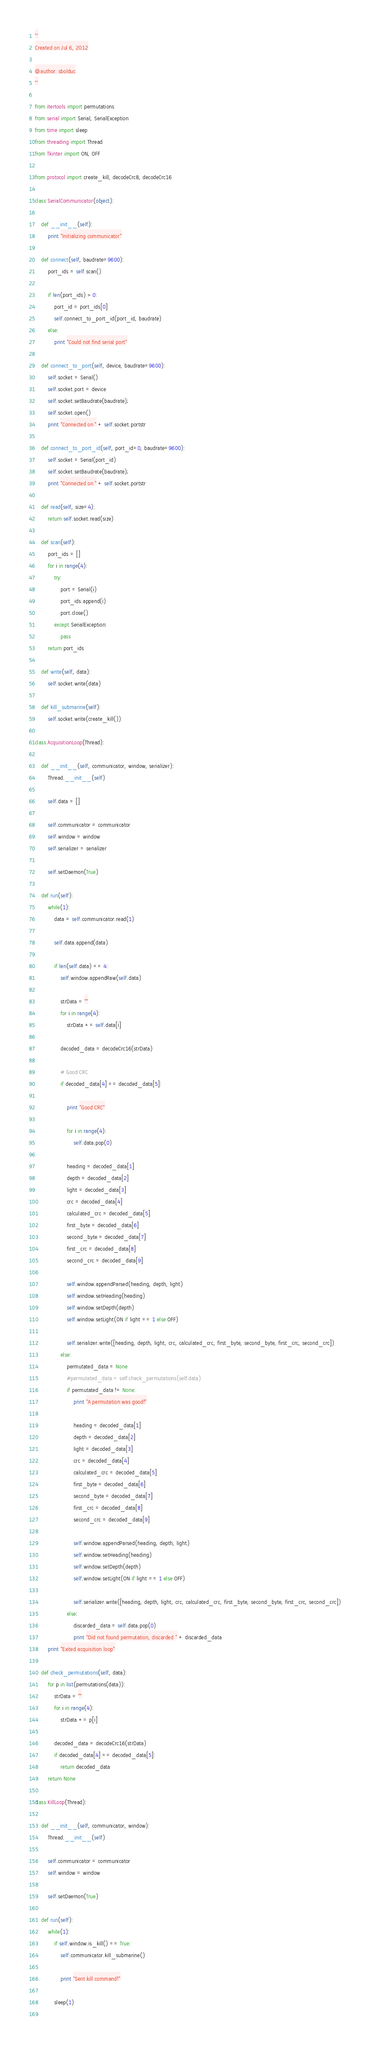<code> <loc_0><loc_0><loc_500><loc_500><_Python_>'''
Created on Jul 6, 2012

@author: sbolduc
'''

from itertools import permutations
from serial import Serial, SerialException
from time import sleep
from threading import Thread
from Tkinter import ON, OFF

from protocol import create_kill, decodeCrc8, decodeCrc16

class SerialCommunicator(object):

    def __init__(self):
        print "Initializing communicator"
            
    def connect(self, baudrate=9600):
        port_ids = self.scan()
        
        if len(port_ids) > 0:
            port_id = port_ids[0]
            self.connect_to_port_id(port_id, baudrate)
        else:
            print "Could not find serial port"
            
    def connect_to_port(self, device, baudrate=9600):
        self.socket = Serial()
        self.socket.port = device
        self.socket.setBaudrate(baudrate);
        self.socket.open()
        print "Connected on " + self.socket.portstr
        
    def connect_to_port_id(self, port_id=0, baudrate=9600):
        self.socket = Serial(port_id)
        self.socket.setBaudrate(baudrate);
        print "Connected on " + self.socket.portstr
        
    def read(self, size=4):
        return self.socket.read(size)
    
    def scan(self):
        port_ids = []
        for i in range(4):
            try:
                port = Serial(i)
                port_ids.append(i)
                port.close()
            except SerialException:
                pass
        return port_ids
    
    def write(self, data):
        self.socket.write(data)
    
    def kill_submarine(self):
        self.socket.write(create_kill())

class AcquisitionLoop(Thread):

    def __init__(self, communicator, window, serializer):
        Thread.__init__(self) 
        
        self.data = []
        
        self.communicator = communicator
        self.window = window
        self.serializer = serializer
        
        self.setDaemon(True)

    def run(self):
        while(1):
            data = self.communicator.read(1)
            
            self.data.append(data)
            
            if len(self.data) == 4:
                self.window.appendRaw(self.data)
                
                strData = ""
                for i in range(4):
                    strData += self.data[i]
                    
                decoded_data = decodeCrc16(strData)
                
                # Good CRC
                if decoded_data[4] == decoded_data[5]:
                    
                    print "Good CRC"
                    
                    for i in range(4):
                        self.data.pop(0)
                        
                    heading = decoded_data[1]
                    depth = decoded_data[2]
                    light = decoded_data[3]
                    crc = decoded_data[4]
                    calculated_crc = decoded_data[5]
                    first_byte = decoded_data[6]
                    second_byte = decoded_data[7]
                    first_crc = decoded_data[8]
                    second_crc = decoded_data[9]
                
                    self.window.appendParsed(heading, depth, light)
                    self.window.setHeading(heading)
                    self.window.setDepth(depth)
                    self.window.setLight(ON if light == 1 else OFF)
                        
                    self.serializer.write([heading, depth, light, crc, calculated_crc, first_byte, second_byte, first_crc, second_crc])
                else:
                    permutated_data = None
                    #permutated_data = self.check_permutations(self.data)
                    if permutated_data != None:
                        print "A permutation was good!"
                        
                        heading = decoded_data[1]
                        depth = decoded_data[2]
                        light = decoded_data[3]
                        crc = decoded_data[4]
                        calculated_crc = decoded_data[5]
                        first_byte = decoded_data[6]
                        second_byte = decoded_data[7]
                        first_crc = decoded_data[8]
                        second_crc = decoded_data[9]
                    
                        self.window.appendParsed(heading, depth, light)
                        self.window.setHeading(heading)
                        self.window.setDepth(depth)
                        self.window.setLight(ON if light == 1 else OFF)
                            
                        self.serializer.write([heading, depth, light, crc, calculated_crc, first_byte, second_byte, first_crc, second_crc])
                    else:
                        discarded_data = self.data.pop(0)
                        print "Did not found permutation, discarded " + discarded_data
        print "Exited acquisition loop"

    def check_permutations(self, data):
        for p in list(permutations(data)):
            strData = ""
            for i in range(4):
                strData += p[i]
                            
            decoded_data = decodeCrc16(strData)
            if decoded_data[4] == decoded_data[5]:
                return decoded_data
        return None

class KillLoop(Thread):

    def __init__(self, communicator, window):
        Thread.__init__(self)
        
        self.communicator = communicator
        self.window = window
        
        self.setDaemon(True)

    def run(self):
        while(1):
            if self.window.is_kill() == True:
                self.communicator.kill_submarine()
                
                print "Sent kill command!"
            
            sleep(1)
                
</code> 